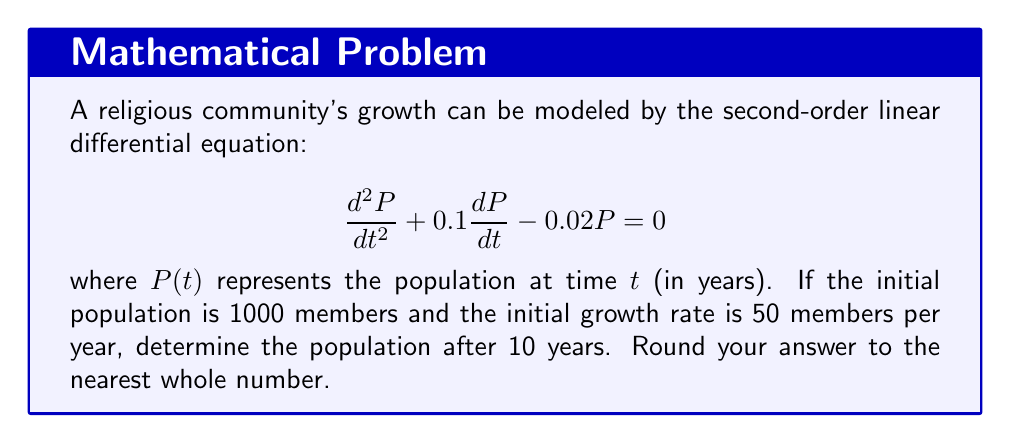Solve this math problem. To solve this problem, we need to follow these steps:

1) First, we need to find the general solution of the differential equation. The characteristic equation is:

   $$r^2 + 0.1r - 0.02 = 0$$

2) Solving this quadratic equation:
   
   $$r = \frac{-0.1 \pm \sqrt{0.01 + 0.08}}{2} = \frac{-0.1 \pm \sqrt{0.09}}{2} = \frac{-0.1 \pm 0.3}{2}$$

3) This gives us two roots: $r_1 = 0.1$ and $r_2 = -0.2$

4) Therefore, the general solution is:

   $$P(t) = C_1e^{0.1t} + C_2e^{-0.2t}$$

5) Now we use the initial conditions to find $C_1$ and $C_2$:
   
   At $t=0$, $P(0) = 1000$, so:
   $$1000 = C_1 + C_2$$

   The initial growth rate is given by $P'(0) = 50$:
   $$50 = 0.1C_1 - 0.2C_2$$

6) Solving these equations simultaneously:
   
   $$C_1 = 1166.67, C_2 = -166.67$$

7) Our particular solution is:

   $$P(t) = 1166.67e^{0.1t} - 166.67e^{-0.2t}$$

8) To find the population after 10 years, we substitute $t=10$:

   $$P(10) = 1166.67e^{1} - 166.67e^{-2} = 3168.49 - 22.56 = 3145.93$$

9) Rounding to the nearest whole number:

   $$P(10) \approx 3146$$
Answer: 3146 members 